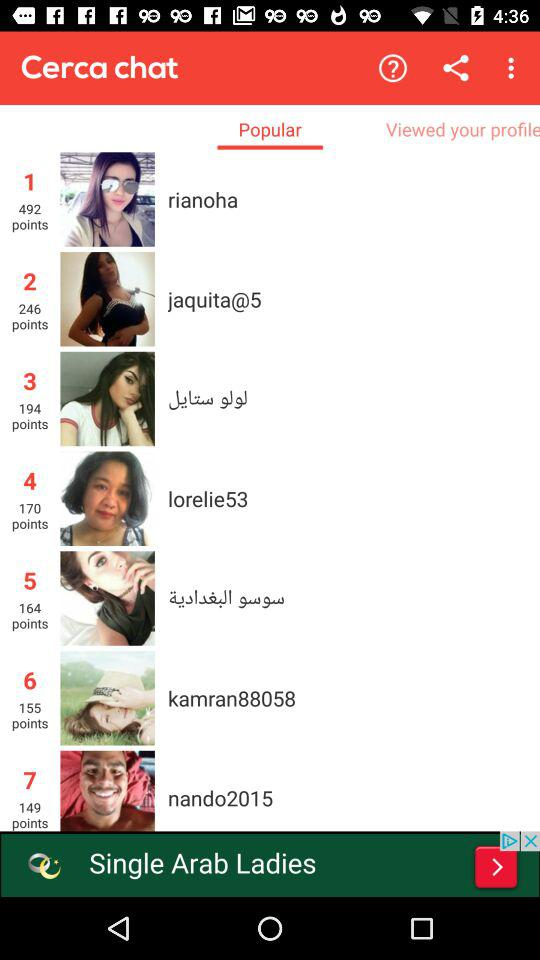How many points does the person with the highest number of points have?
Answer the question using a single word or phrase. 492 